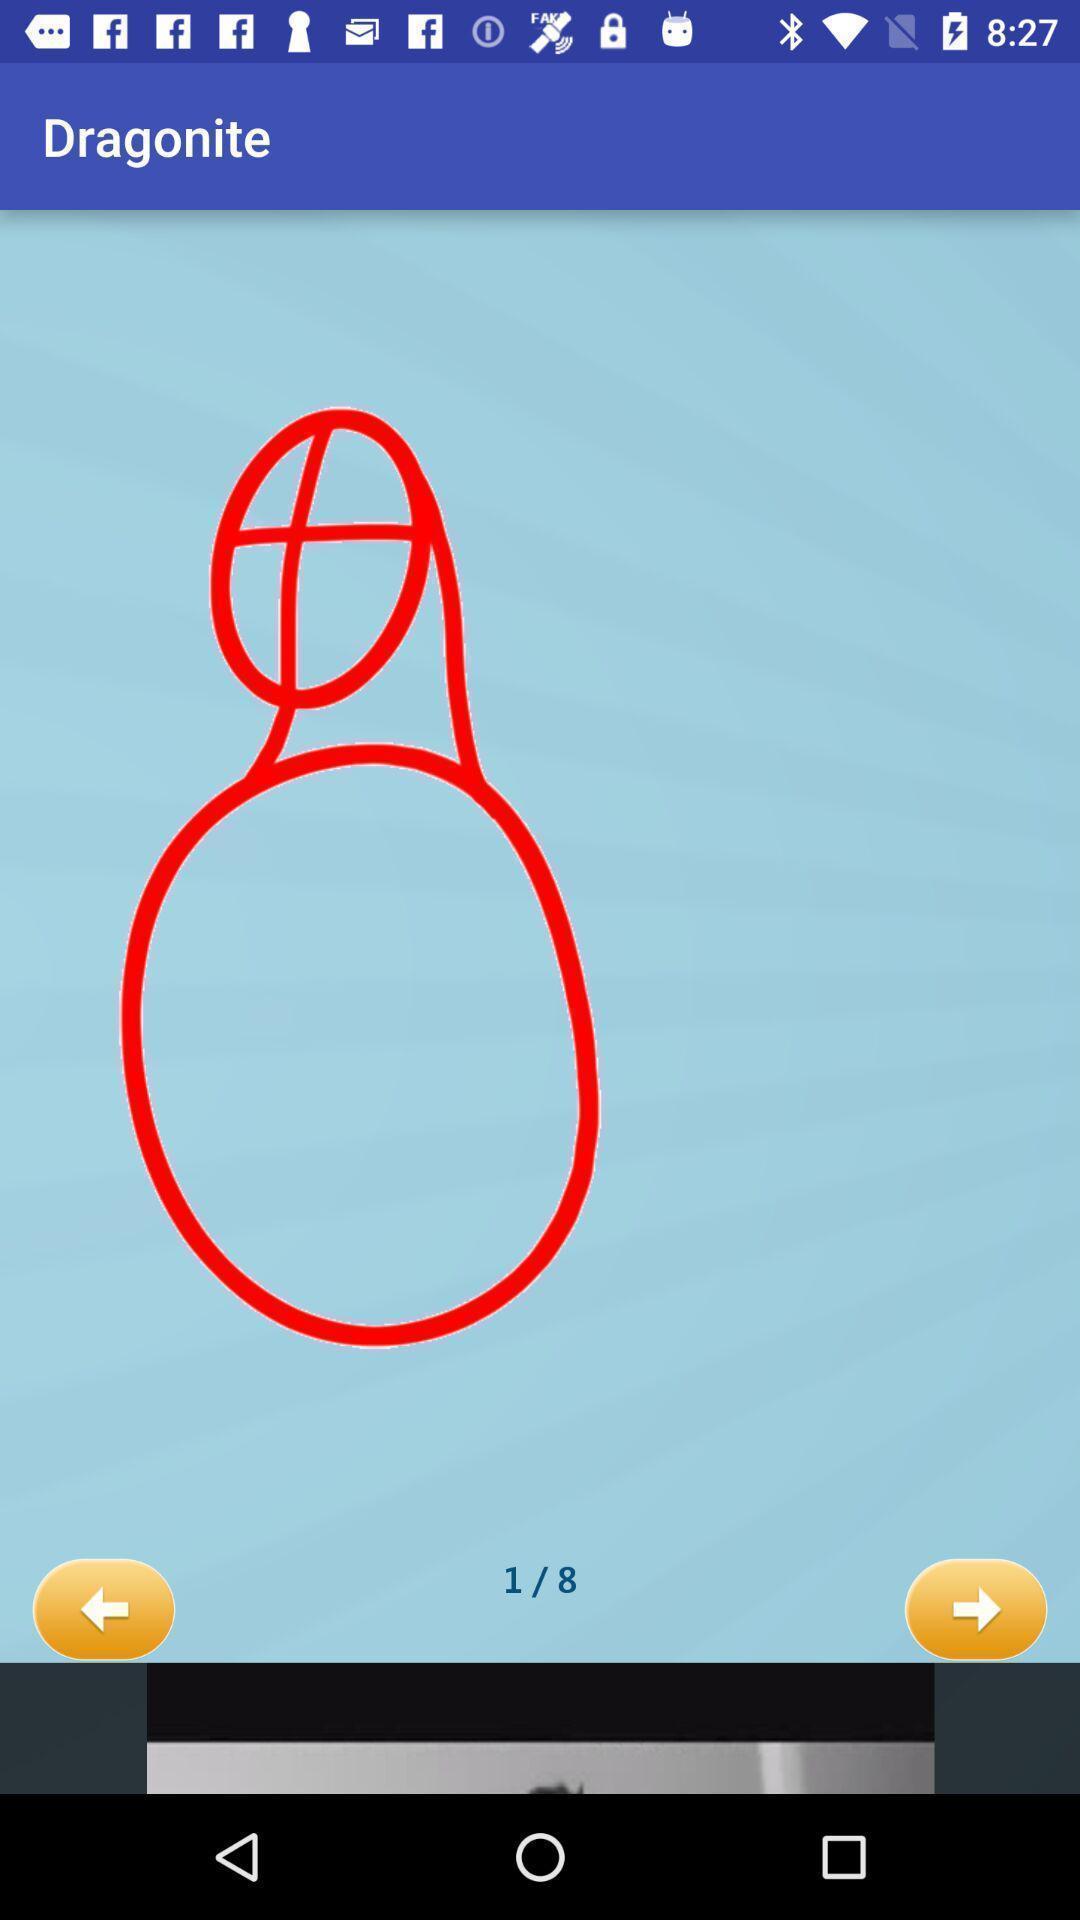Describe the visual elements of this screenshot. Screen is showing page of an drawing application. 